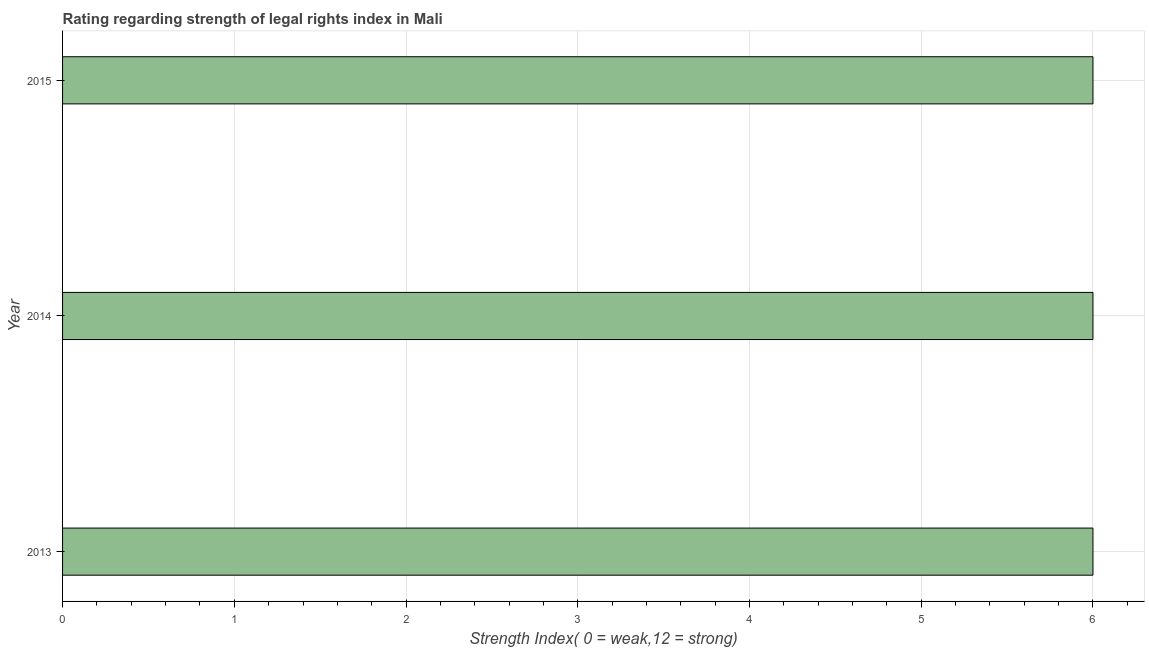Does the graph contain any zero values?
Provide a succinct answer. No. Does the graph contain grids?
Your answer should be very brief. Yes. What is the title of the graph?
Provide a short and direct response. Rating regarding strength of legal rights index in Mali. What is the label or title of the X-axis?
Provide a succinct answer. Strength Index( 0 = weak,12 = strong). What is the label or title of the Y-axis?
Offer a terse response. Year. Across all years, what is the maximum strength of legal rights index?
Your answer should be compact. 6. What is the sum of the strength of legal rights index?
Provide a short and direct response. 18. What is the average strength of legal rights index per year?
Your answer should be very brief. 6. What is the median strength of legal rights index?
Your answer should be very brief. 6. In how many years, is the strength of legal rights index greater than 5.6 ?
Provide a short and direct response. 3. Is the difference between the strength of legal rights index in 2014 and 2015 greater than the difference between any two years?
Ensure brevity in your answer.  Yes. Are all the bars in the graph horizontal?
Your answer should be very brief. Yes. How many years are there in the graph?
Give a very brief answer. 3. Are the values on the major ticks of X-axis written in scientific E-notation?
Make the answer very short. No. What is the Strength Index( 0 = weak,12 = strong) of 2013?
Offer a terse response. 6. What is the Strength Index( 0 = weak,12 = strong) of 2014?
Your answer should be compact. 6. What is the Strength Index( 0 = weak,12 = strong) of 2015?
Make the answer very short. 6. What is the difference between the Strength Index( 0 = weak,12 = strong) in 2013 and 2014?
Keep it short and to the point. 0. What is the ratio of the Strength Index( 0 = weak,12 = strong) in 2013 to that in 2014?
Your response must be concise. 1. 